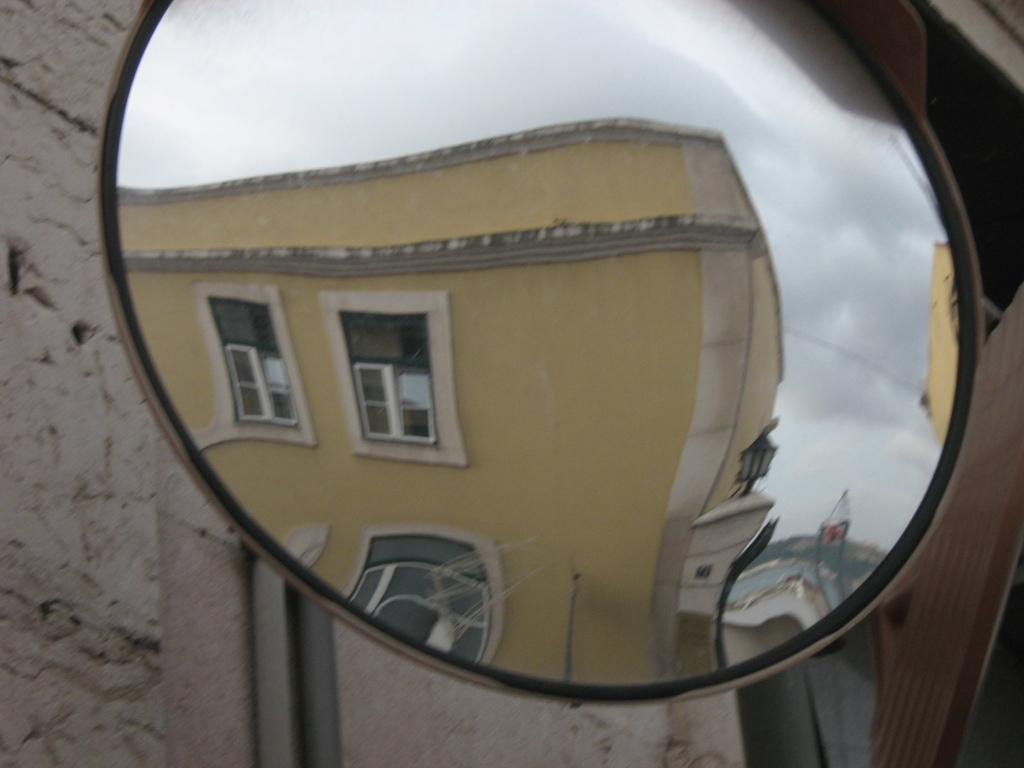What is being reflected in the image? There is a reflection of buildings, light, and the sky in the image. What is the surface that is reflecting these elements? The reflection is on a road safety mirror. What can be seen in the background of the image? There is a wall in the background of the image. How many sisters are reading books in the image? There are no sisters or books present in the image; it features a reflection on a road safety mirror. 